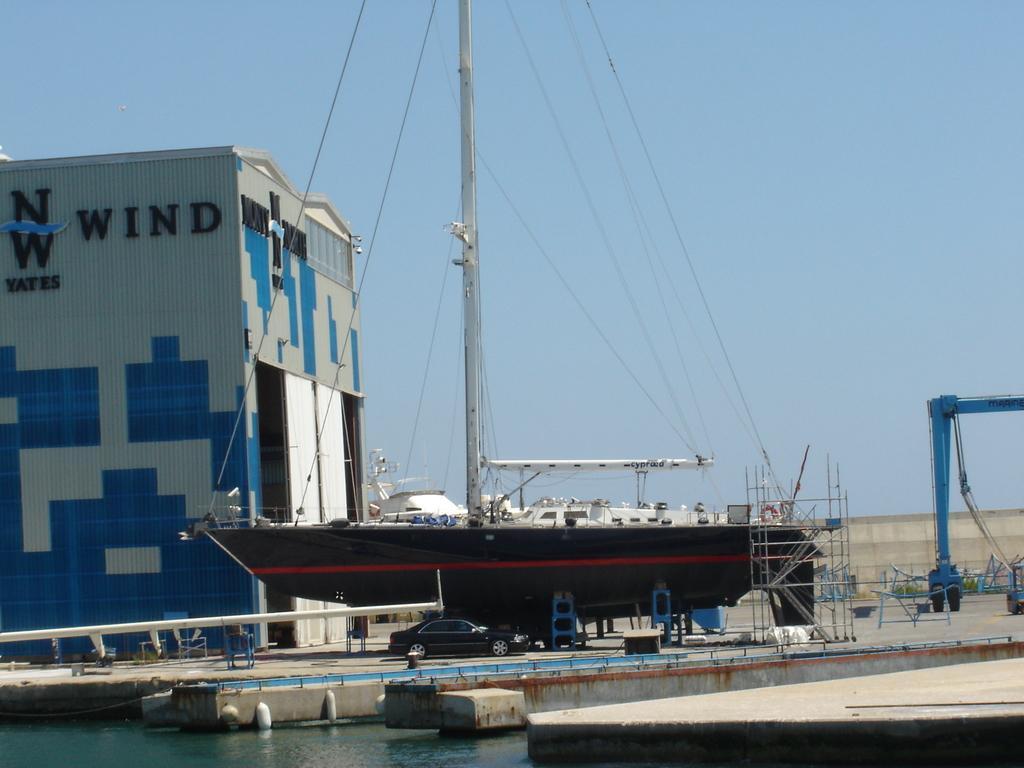Describe this image in one or two sentences. In this picture we can see some vehicles and ship are placed beside the water. 